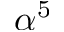<formula> <loc_0><loc_0><loc_500><loc_500>\alpha ^ { 5 }</formula> 